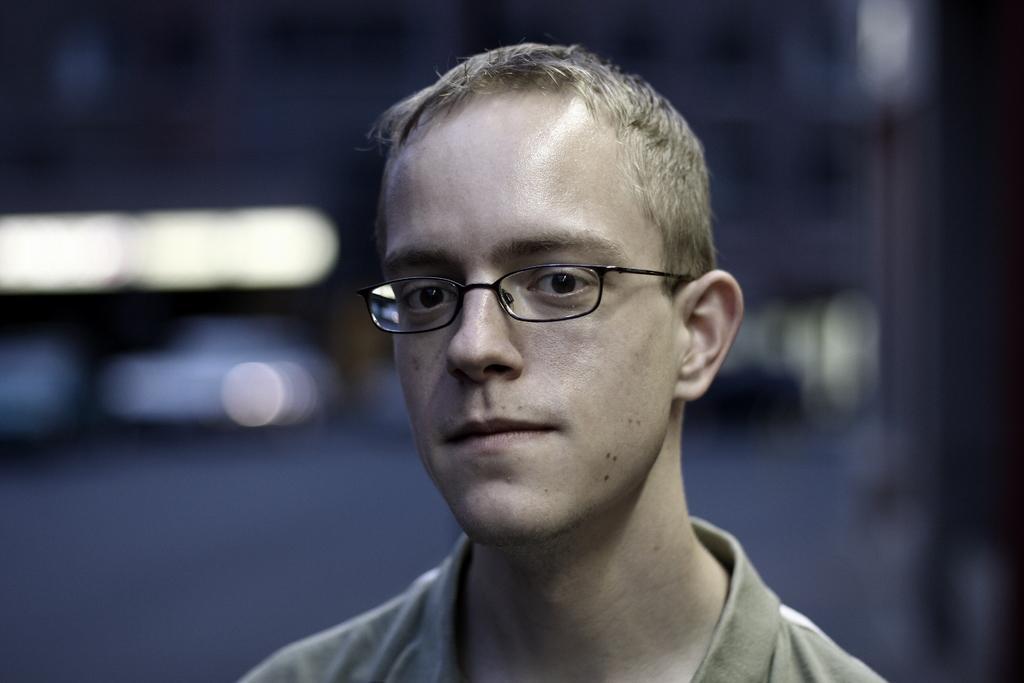Describe this image in one or two sentences. Here a man is looking at this side. He wore a t-shirt, spectacles. 